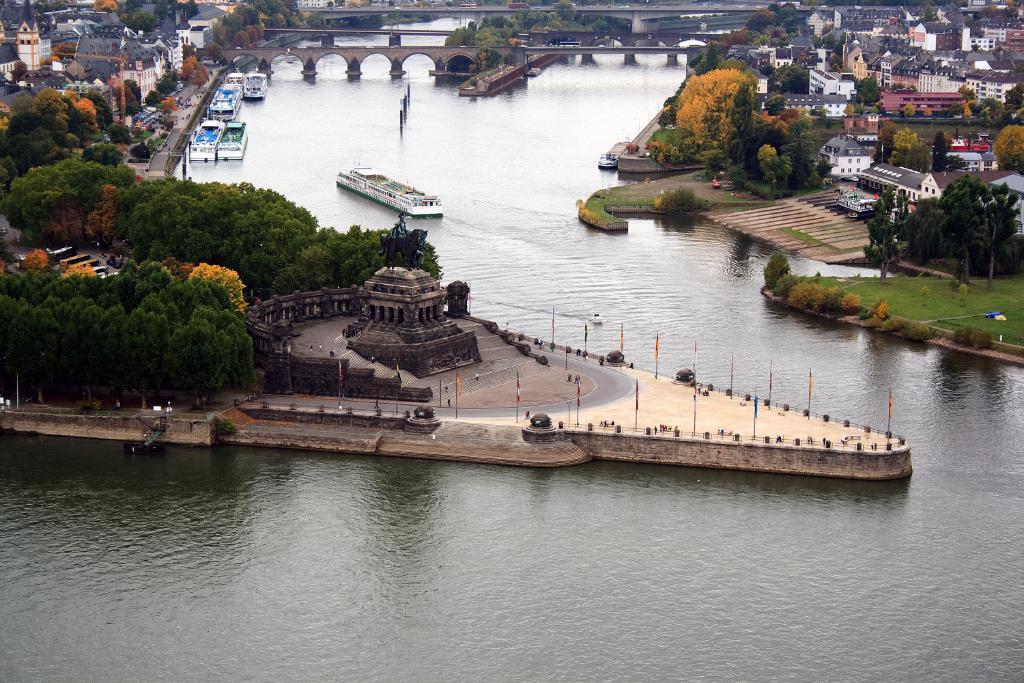Can you describe this image briefly? The picture is an aerial view of a city. The picture consists of buildings, trees, ships, bridges, flags, plants, grass and a water body. 